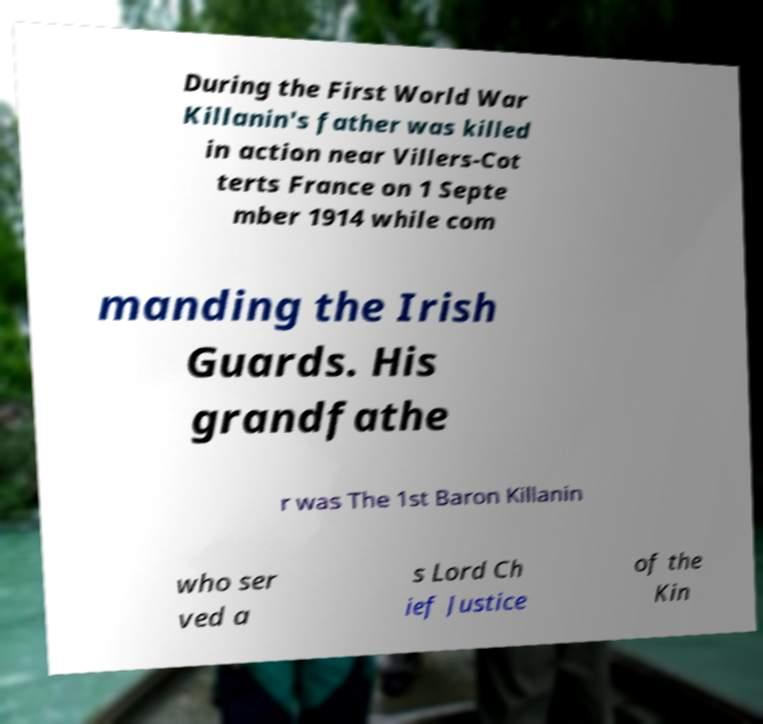Could you assist in decoding the text presented in this image and type it out clearly? During the First World War Killanin's father was killed in action near Villers-Cot terts France on 1 Septe mber 1914 while com manding the Irish Guards. His grandfathe r was The 1st Baron Killanin who ser ved a s Lord Ch ief Justice of the Kin 